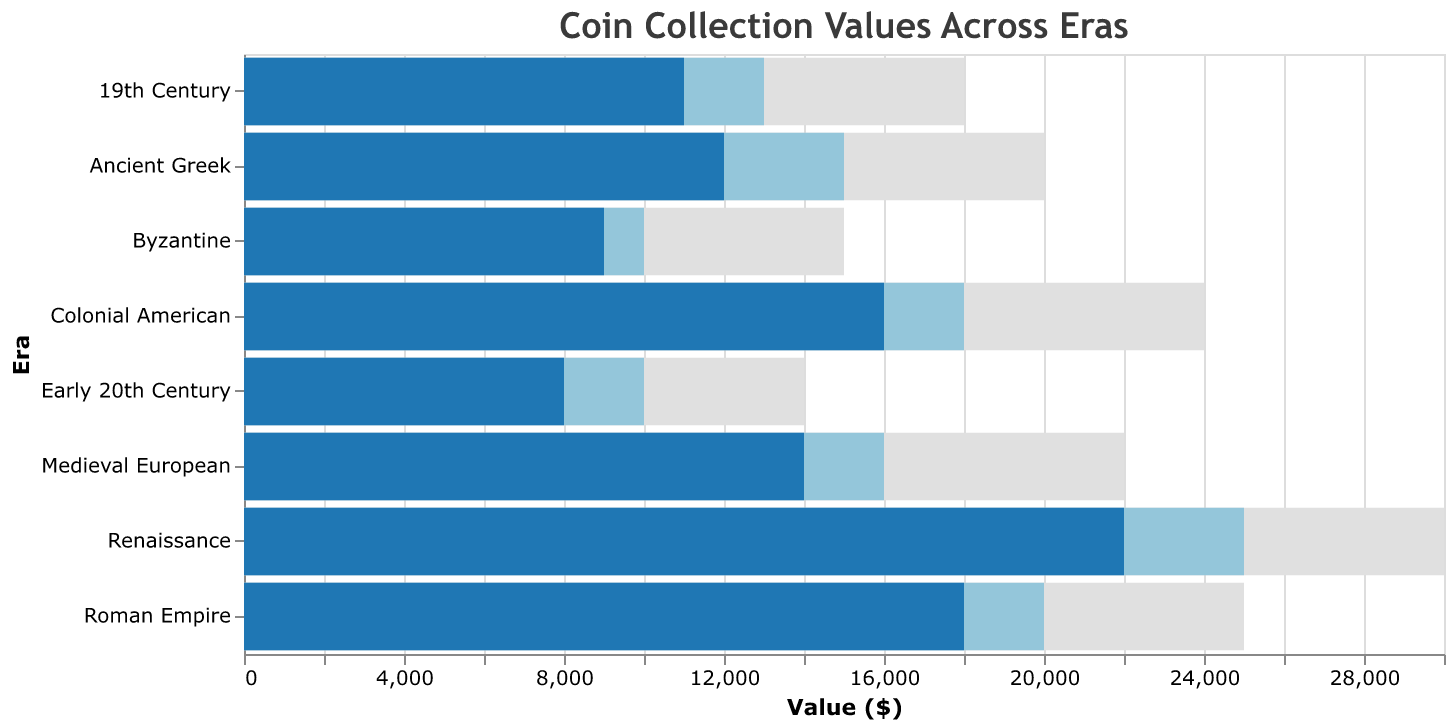What is the maximum value for the Roman Empire era? To find the maximum value for the Roman Empire era, look at the corresponding era label and read the maximum value from the chart.
Answer: 25000 How many eras have an actual value greater than 15000? Identify the actual values of each era, then count how many exceed 15000. Ancient Greek: 12000, Roman Empire: 18000, Byzantine: 9000, Medieval European: 14000, Renaissance: 22000, Colonial American: 16000, 19th Century: 11000, Early 20th Century: 8000. Out of these, Roman Empire, Renaissance, and Colonial American are greater than 15000.
Answer: 3 Which era has the highest actual value? Compare the actual values of all the eras and determine which one is the largest. Ancient Greek: 12000, Roman Empire: 18000, Byzantine: 9000, Medieval European: 14000, Renaissance: 22000, Colonial American: 16000, 19th Century: 11000, Early 20th Century: 8000. Renaissance has the highest actual value.
Answer: Renaissance Is the actual value for the Renaissance era higher than its target value? Compare the actual value and the target value for the Renaissance era. The actual value is 22000, and the target value is 25000.
Answer: No Which era has the smallest difference between its actual value and target value? Calculate the difference between the actual value and the target value for each era. Ancient Greek: 3000, Roman Empire: 2000, Byzantine: 1000, Medieval European: 2000, Renaissance: 3000, Colonial American: 2000, 19th Century: 2000, Early 20th Century: 2000. Byzantine has the smallest difference.
Answer: Byzantine What is the total target value for all eras combined? Sum the target values for all eras. 15000 (Ancient Greek) + 20000 (Roman Empire) + 10000 (Byzantine) + 16000 (Medieval European) + 25000 (Renaissance) + 18000 (Colonial American) + 13000 (19th Century) + 10000 (Early 20th Century).
Answer: 127000 Are there any eras where the actual value equals the target value? Check if any era has an actual value that matches its target value. Ancient Greek: No, Roman Empire: No, Byzantine: No, Medieval European: No, Renaissance: No, Colonial American: No, 19th Century: No, Early 20th Century: No.
Answer: No How much less is the actual value of the Early 20th Century era compared to its target value? Subtract the actual value of the Early 20th Century era from its target value. Target value: 10000, Actual value: 8000. Difference: 10000 - 8000.
Answer: 2000 